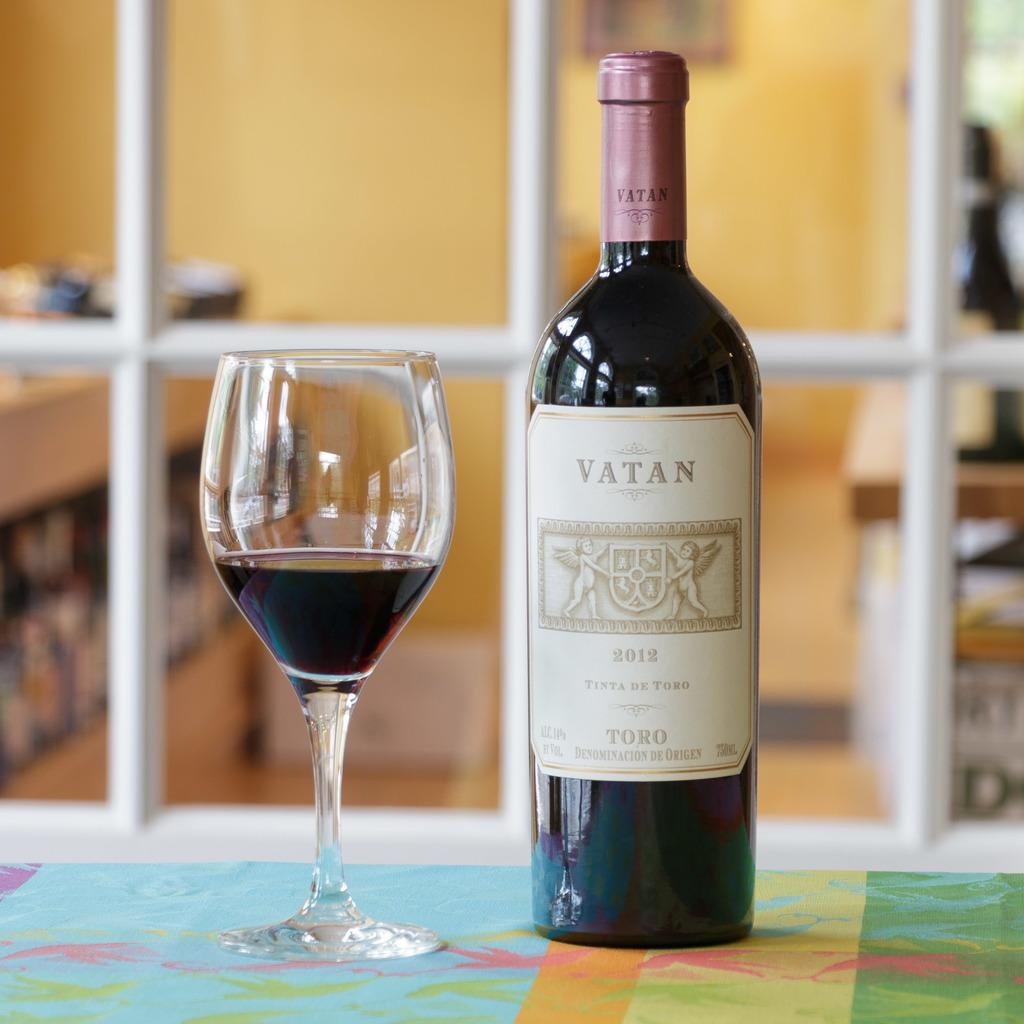<image>
Offer a succinct explanation of the picture presented. Bottle of Vatan on a table next to a cup of wine. 